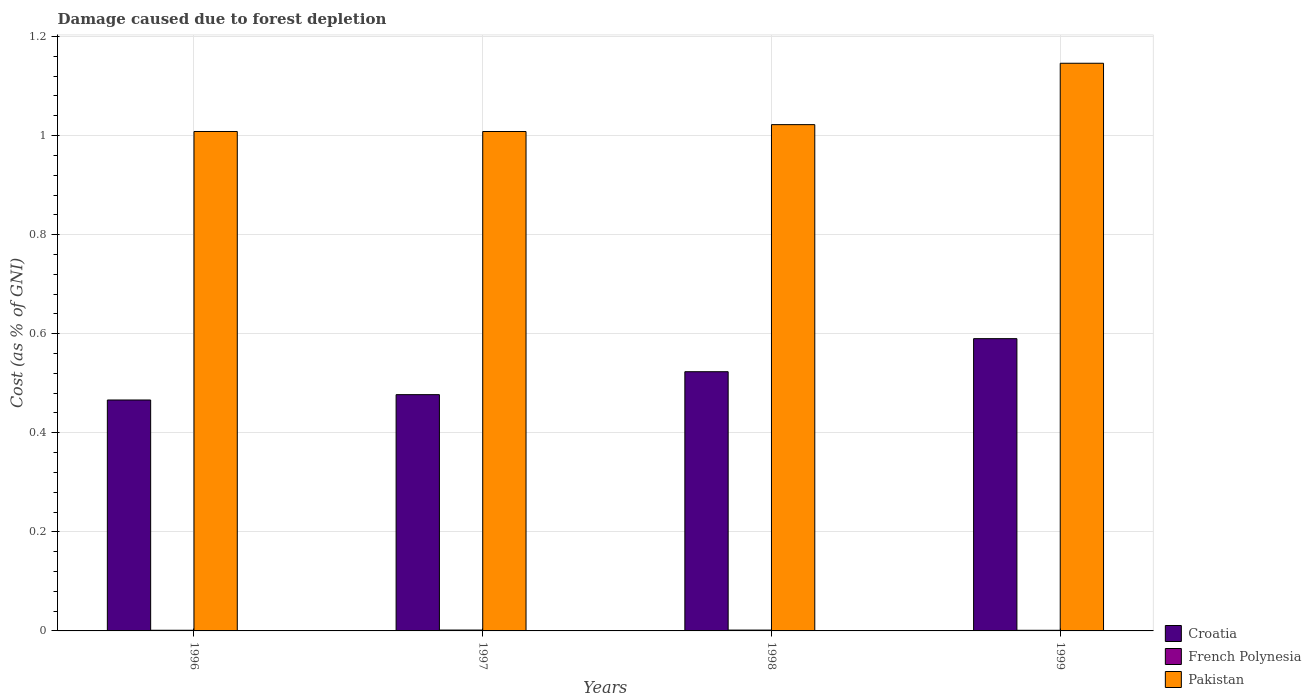How many different coloured bars are there?
Your response must be concise. 3. Are the number of bars on each tick of the X-axis equal?
Give a very brief answer. Yes. How many bars are there on the 2nd tick from the left?
Make the answer very short. 3. How many bars are there on the 1st tick from the right?
Offer a terse response. 3. What is the cost of damage caused due to forest depletion in Croatia in 1999?
Give a very brief answer. 0.59. Across all years, what is the maximum cost of damage caused due to forest depletion in French Polynesia?
Give a very brief answer. 0. Across all years, what is the minimum cost of damage caused due to forest depletion in French Polynesia?
Your answer should be very brief. 0. In which year was the cost of damage caused due to forest depletion in Croatia minimum?
Ensure brevity in your answer.  1996. What is the total cost of damage caused due to forest depletion in Pakistan in the graph?
Offer a very short reply. 4.18. What is the difference between the cost of damage caused due to forest depletion in Pakistan in 1998 and that in 1999?
Provide a succinct answer. -0.12. What is the difference between the cost of damage caused due to forest depletion in Croatia in 1998 and the cost of damage caused due to forest depletion in Pakistan in 1996?
Ensure brevity in your answer.  -0.48. What is the average cost of damage caused due to forest depletion in Croatia per year?
Your response must be concise. 0.51. In the year 1999, what is the difference between the cost of damage caused due to forest depletion in French Polynesia and cost of damage caused due to forest depletion in Pakistan?
Your answer should be very brief. -1.14. What is the ratio of the cost of damage caused due to forest depletion in French Polynesia in 1996 to that in 1997?
Ensure brevity in your answer.  0.77. Is the cost of damage caused due to forest depletion in Pakistan in 1996 less than that in 1998?
Provide a succinct answer. Yes. What is the difference between the highest and the second highest cost of damage caused due to forest depletion in Croatia?
Ensure brevity in your answer.  0.07. What is the difference between the highest and the lowest cost of damage caused due to forest depletion in French Polynesia?
Provide a succinct answer. 0. Is the sum of the cost of damage caused due to forest depletion in French Polynesia in 1996 and 1998 greater than the maximum cost of damage caused due to forest depletion in Croatia across all years?
Your answer should be very brief. No. What does the 1st bar from the left in 1998 represents?
Your answer should be very brief. Croatia. What does the 3rd bar from the right in 1998 represents?
Make the answer very short. Croatia. Is it the case that in every year, the sum of the cost of damage caused due to forest depletion in Pakistan and cost of damage caused due to forest depletion in Croatia is greater than the cost of damage caused due to forest depletion in French Polynesia?
Your answer should be compact. Yes. Are all the bars in the graph horizontal?
Make the answer very short. No. How many years are there in the graph?
Your answer should be compact. 4. What is the difference between two consecutive major ticks on the Y-axis?
Ensure brevity in your answer.  0.2. Are the values on the major ticks of Y-axis written in scientific E-notation?
Keep it short and to the point. No. What is the title of the graph?
Offer a very short reply. Damage caused due to forest depletion. What is the label or title of the Y-axis?
Ensure brevity in your answer.  Cost (as % of GNI). What is the Cost (as % of GNI) of Croatia in 1996?
Make the answer very short. 0.47. What is the Cost (as % of GNI) in French Polynesia in 1996?
Your answer should be compact. 0. What is the Cost (as % of GNI) in Pakistan in 1996?
Provide a succinct answer. 1.01. What is the Cost (as % of GNI) of Croatia in 1997?
Your answer should be compact. 0.48. What is the Cost (as % of GNI) in French Polynesia in 1997?
Give a very brief answer. 0. What is the Cost (as % of GNI) of Pakistan in 1997?
Your answer should be compact. 1.01. What is the Cost (as % of GNI) in Croatia in 1998?
Provide a succinct answer. 0.52. What is the Cost (as % of GNI) in French Polynesia in 1998?
Offer a terse response. 0. What is the Cost (as % of GNI) of Pakistan in 1998?
Your response must be concise. 1.02. What is the Cost (as % of GNI) in Croatia in 1999?
Give a very brief answer. 0.59. What is the Cost (as % of GNI) in French Polynesia in 1999?
Offer a terse response. 0. What is the Cost (as % of GNI) of Pakistan in 1999?
Ensure brevity in your answer.  1.15. Across all years, what is the maximum Cost (as % of GNI) of Croatia?
Give a very brief answer. 0.59. Across all years, what is the maximum Cost (as % of GNI) in French Polynesia?
Your answer should be very brief. 0. Across all years, what is the maximum Cost (as % of GNI) of Pakistan?
Keep it short and to the point. 1.15. Across all years, what is the minimum Cost (as % of GNI) of Croatia?
Your answer should be compact. 0.47. Across all years, what is the minimum Cost (as % of GNI) in French Polynesia?
Your answer should be very brief. 0. Across all years, what is the minimum Cost (as % of GNI) in Pakistan?
Ensure brevity in your answer.  1.01. What is the total Cost (as % of GNI) of Croatia in the graph?
Make the answer very short. 2.06. What is the total Cost (as % of GNI) of French Polynesia in the graph?
Your answer should be very brief. 0.01. What is the total Cost (as % of GNI) in Pakistan in the graph?
Provide a succinct answer. 4.18. What is the difference between the Cost (as % of GNI) of Croatia in 1996 and that in 1997?
Give a very brief answer. -0.01. What is the difference between the Cost (as % of GNI) of French Polynesia in 1996 and that in 1997?
Give a very brief answer. -0. What is the difference between the Cost (as % of GNI) of Pakistan in 1996 and that in 1997?
Keep it short and to the point. 0. What is the difference between the Cost (as % of GNI) of Croatia in 1996 and that in 1998?
Your response must be concise. -0.06. What is the difference between the Cost (as % of GNI) of French Polynesia in 1996 and that in 1998?
Your response must be concise. -0. What is the difference between the Cost (as % of GNI) in Pakistan in 1996 and that in 1998?
Your response must be concise. -0.01. What is the difference between the Cost (as % of GNI) of Croatia in 1996 and that in 1999?
Give a very brief answer. -0.12. What is the difference between the Cost (as % of GNI) in French Polynesia in 1996 and that in 1999?
Your answer should be very brief. 0. What is the difference between the Cost (as % of GNI) in Pakistan in 1996 and that in 1999?
Offer a very short reply. -0.14. What is the difference between the Cost (as % of GNI) in Croatia in 1997 and that in 1998?
Offer a very short reply. -0.05. What is the difference between the Cost (as % of GNI) of Pakistan in 1997 and that in 1998?
Make the answer very short. -0.01. What is the difference between the Cost (as % of GNI) in Croatia in 1997 and that in 1999?
Make the answer very short. -0.11. What is the difference between the Cost (as % of GNI) in French Polynesia in 1997 and that in 1999?
Give a very brief answer. 0. What is the difference between the Cost (as % of GNI) of Pakistan in 1997 and that in 1999?
Offer a very short reply. -0.14. What is the difference between the Cost (as % of GNI) of Croatia in 1998 and that in 1999?
Your answer should be very brief. -0.07. What is the difference between the Cost (as % of GNI) in Pakistan in 1998 and that in 1999?
Offer a terse response. -0.12. What is the difference between the Cost (as % of GNI) in Croatia in 1996 and the Cost (as % of GNI) in French Polynesia in 1997?
Offer a terse response. 0.46. What is the difference between the Cost (as % of GNI) of Croatia in 1996 and the Cost (as % of GNI) of Pakistan in 1997?
Offer a terse response. -0.54. What is the difference between the Cost (as % of GNI) in French Polynesia in 1996 and the Cost (as % of GNI) in Pakistan in 1997?
Offer a terse response. -1.01. What is the difference between the Cost (as % of GNI) in Croatia in 1996 and the Cost (as % of GNI) in French Polynesia in 1998?
Make the answer very short. 0.46. What is the difference between the Cost (as % of GNI) in Croatia in 1996 and the Cost (as % of GNI) in Pakistan in 1998?
Your answer should be very brief. -0.56. What is the difference between the Cost (as % of GNI) of French Polynesia in 1996 and the Cost (as % of GNI) of Pakistan in 1998?
Offer a terse response. -1.02. What is the difference between the Cost (as % of GNI) in Croatia in 1996 and the Cost (as % of GNI) in French Polynesia in 1999?
Offer a terse response. 0.46. What is the difference between the Cost (as % of GNI) in Croatia in 1996 and the Cost (as % of GNI) in Pakistan in 1999?
Give a very brief answer. -0.68. What is the difference between the Cost (as % of GNI) of French Polynesia in 1996 and the Cost (as % of GNI) of Pakistan in 1999?
Provide a succinct answer. -1.14. What is the difference between the Cost (as % of GNI) of Croatia in 1997 and the Cost (as % of GNI) of French Polynesia in 1998?
Keep it short and to the point. 0.48. What is the difference between the Cost (as % of GNI) in Croatia in 1997 and the Cost (as % of GNI) in Pakistan in 1998?
Offer a terse response. -0.55. What is the difference between the Cost (as % of GNI) of French Polynesia in 1997 and the Cost (as % of GNI) of Pakistan in 1998?
Your answer should be compact. -1.02. What is the difference between the Cost (as % of GNI) in Croatia in 1997 and the Cost (as % of GNI) in French Polynesia in 1999?
Keep it short and to the point. 0.48. What is the difference between the Cost (as % of GNI) of Croatia in 1997 and the Cost (as % of GNI) of Pakistan in 1999?
Ensure brevity in your answer.  -0.67. What is the difference between the Cost (as % of GNI) in French Polynesia in 1997 and the Cost (as % of GNI) in Pakistan in 1999?
Keep it short and to the point. -1.14. What is the difference between the Cost (as % of GNI) in Croatia in 1998 and the Cost (as % of GNI) in French Polynesia in 1999?
Your answer should be compact. 0.52. What is the difference between the Cost (as % of GNI) of Croatia in 1998 and the Cost (as % of GNI) of Pakistan in 1999?
Offer a very short reply. -0.62. What is the difference between the Cost (as % of GNI) in French Polynesia in 1998 and the Cost (as % of GNI) in Pakistan in 1999?
Your answer should be very brief. -1.14. What is the average Cost (as % of GNI) in Croatia per year?
Your answer should be compact. 0.51. What is the average Cost (as % of GNI) of French Polynesia per year?
Give a very brief answer. 0. What is the average Cost (as % of GNI) of Pakistan per year?
Offer a very short reply. 1.05. In the year 1996, what is the difference between the Cost (as % of GNI) of Croatia and Cost (as % of GNI) of French Polynesia?
Keep it short and to the point. 0.46. In the year 1996, what is the difference between the Cost (as % of GNI) of Croatia and Cost (as % of GNI) of Pakistan?
Your answer should be compact. -0.54. In the year 1996, what is the difference between the Cost (as % of GNI) in French Polynesia and Cost (as % of GNI) in Pakistan?
Offer a terse response. -1.01. In the year 1997, what is the difference between the Cost (as % of GNI) of Croatia and Cost (as % of GNI) of French Polynesia?
Offer a very short reply. 0.48. In the year 1997, what is the difference between the Cost (as % of GNI) of Croatia and Cost (as % of GNI) of Pakistan?
Your answer should be compact. -0.53. In the year 1997, what is the difference between the Cost (as % of GNI) of French Polynesia and Cost (as % of GNI) of Pakistan?
Offer a very short reply. -1.01. In the year 1998, what is the difference between the Cost (as % of GNI) in Croatia and Cost (as % of GNI) in French Polynesia?
Your answer should be very brief. 0.52. In the year 1998, what is the difference between the Cost (as % of GNI) of Croatia and Cost (as % of GNI) of Pakistan?
Ensure brevity in your answer.  -0.5. In the year 1998, what is the difference between the Cost (as % of GNI) in French Polynesia and Cost (as % of GNI) in Pakistan?
Keep it short and to the point. -1.02. In the year 1999, what is the difference between the Cost (as % of GNI) of Croatia and Cost (as % of GNI) of French Polynesia?
Your answer should be compact. 0.59. In the year 1999, what is the difference between the Cost (as % of GNI) of Croatia and Cost (as % of GNI) of Pakistan?
Keep it short and to the point. -0.56. In the year 1999, what is the difference between the Cost (as % of GNI) in French Polynesia and Cost (as % of GNI) in Pakistan?
Offer a very short reply. -1.14. What is the ratio of the Cost (as % of GNI) of Croatia in 1996 to that in 1997?
Keep it short and to the point. 0.98. What is the ratio of the Cost (as % of GNI) in French Polynesia in 1996 to that in 1997?
Your answer should be compact. 0.77. What is the ratio of the Cost (as % of GNI) of Croatia in 1996 to that in 1998?
Your response must be concise. 0.89. What is the ratio of the Cost (as % of GNI) in French Polynesia in 1996 to that in 1998?
Your response must be concise. 0.8. What is the ratio of the Cost (as % of GNI) of Pakistan in 1996 to that in 1998?
Offer a very short reply. 0.99. What is the ratio of the Cost (as % of GNI) of Croatia in 1996 to that in 1999?
Your response must be concise. 0.79. What is the ratio of the Cost (as % of GNI) of French Polynesia in 1996 to that in 1999?
Ensure brevity in your answer.  1.07. What is the ratio of the Cost (as % of GNI) in Pakistan in 1996 to that in 1999?
Offer a very short reply. 0.88. What is the ratio of the Cost (as % of GNI) in Croatia in 1997 to that in 1998?
Provide a succinct answer. 0.91. What is the ratio of the Cost (as % of GNI) in French Polynesia in 1997 to that in 1998?
Offer a terse response. 1.04. What is the ratio of the Cost (as % of GNI) of Pakistan in 1997 to that in 1998?
Your answer should be compact. 0.99. What is the ratio of the Cost (as % of GNI) of Croatia in 1997 to that in 1999?
Offer a very short reply. 0.81. What is the ratio of the Cost (as % of GNI) of French Polynesia in 1997 to that in 1999?
Make the answer very short. 1.39. What is the ratio of the Cost (as % of GNI) in Pakistan in 1997 to that in 1999?
Keep it short and to the point. 0.88. What is the ratio of the Cost (as % of GNI) in Croatia in 1998 to that in 1999?
Offer a very short reply. 0.89. What is the ratio of the Cost (as % of GNI) of French Polynesia in 1998 to that in 1999?
Offer a terse response. 1.33. What is the ratio of the Cost (as % of GNI) in Pakistan in 1998 to that in 1999?
Provide a succinct answer. 0.89. What is the difference between the highest and the second highest Cost (as % of GNI) of Croatia?
Offer a very short reply. 0.07. What is the difference between the highest and the second highest Cost (as % of GNI) in Pakistan?
Give a very brief answer. 0.12. What is the difference between the highest and the lowest Cost (as % of GNI) in Croatia?
Make the answer very short. 0.12. What is the difference between the highest and the lowest Cost (as % of GNI) in French Polynesia?
Offer a terse response. 0. What is the difference between the highest and the lowest Cost (as % of GNI) in Pakistan?
Ensure brevity in your answer.  0.14. 